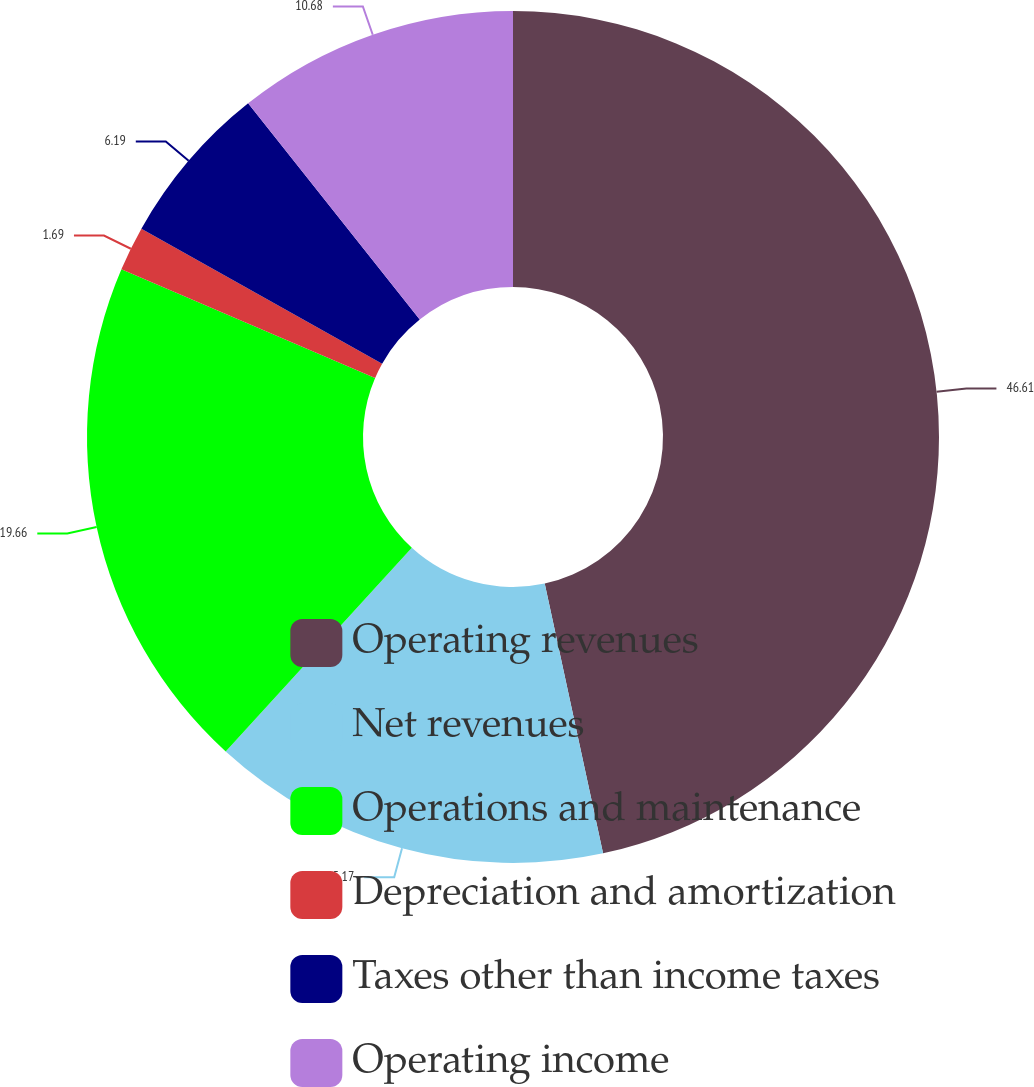<chart> <loc_0><loc_0><loc_500><loc_500><pie_chart><fcel>Operating revenues<fcel>Net revenues<fcel>Operations and maintenance<fcel>Depreciation and amortization<fcel>Taxes other than income taxes<fcel>Operating income<nl><fcel>46.61%<fcel>15.17%<fcel>19.66%<fcel>1.69%<fcel>6.19%<fcel>10.68%<nl></chart> 